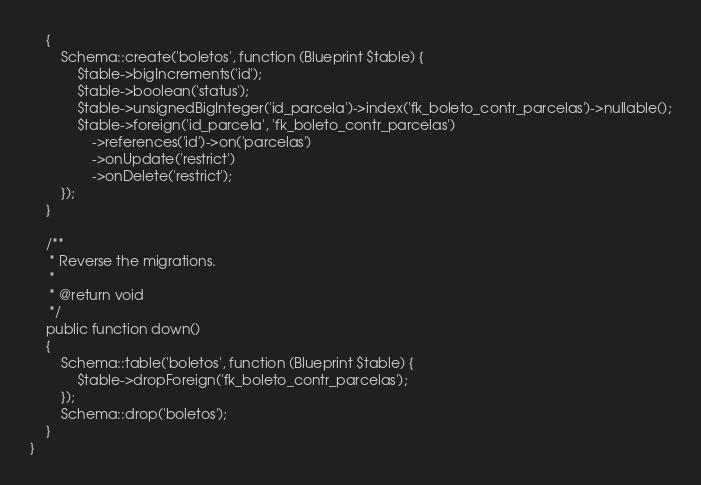Convert code to text. <code><loc_0><loc_0><loc_500><loc_500><_PHP_>    {
        Schema::create('boletos', function (Blueprint $table) {
            $table->bigIncrements('id');
            $table->boolean('status');
            $table->unsignedBigInteger('id_parcela')->index('fk_boleto_contr_parcelas')->nullable();
            $table->foreign('id_parcela', 'fk_boleto_contr_parcelas')
                ->references('id')->on('parcelas')
                ->onUpdate('restrict')
                ->onDelete('restrict');
        });
    }

    /**
     * Reverse the migrations.
     *
     * @return void
     */
    public function down()
    {
        Schema::table('boletos', function (Blueprint $table) {
            $table->dropForeign('fk_boleto_contr_parcelas');
        });
        Schema::drop('boletos');
    }
}
</code> 